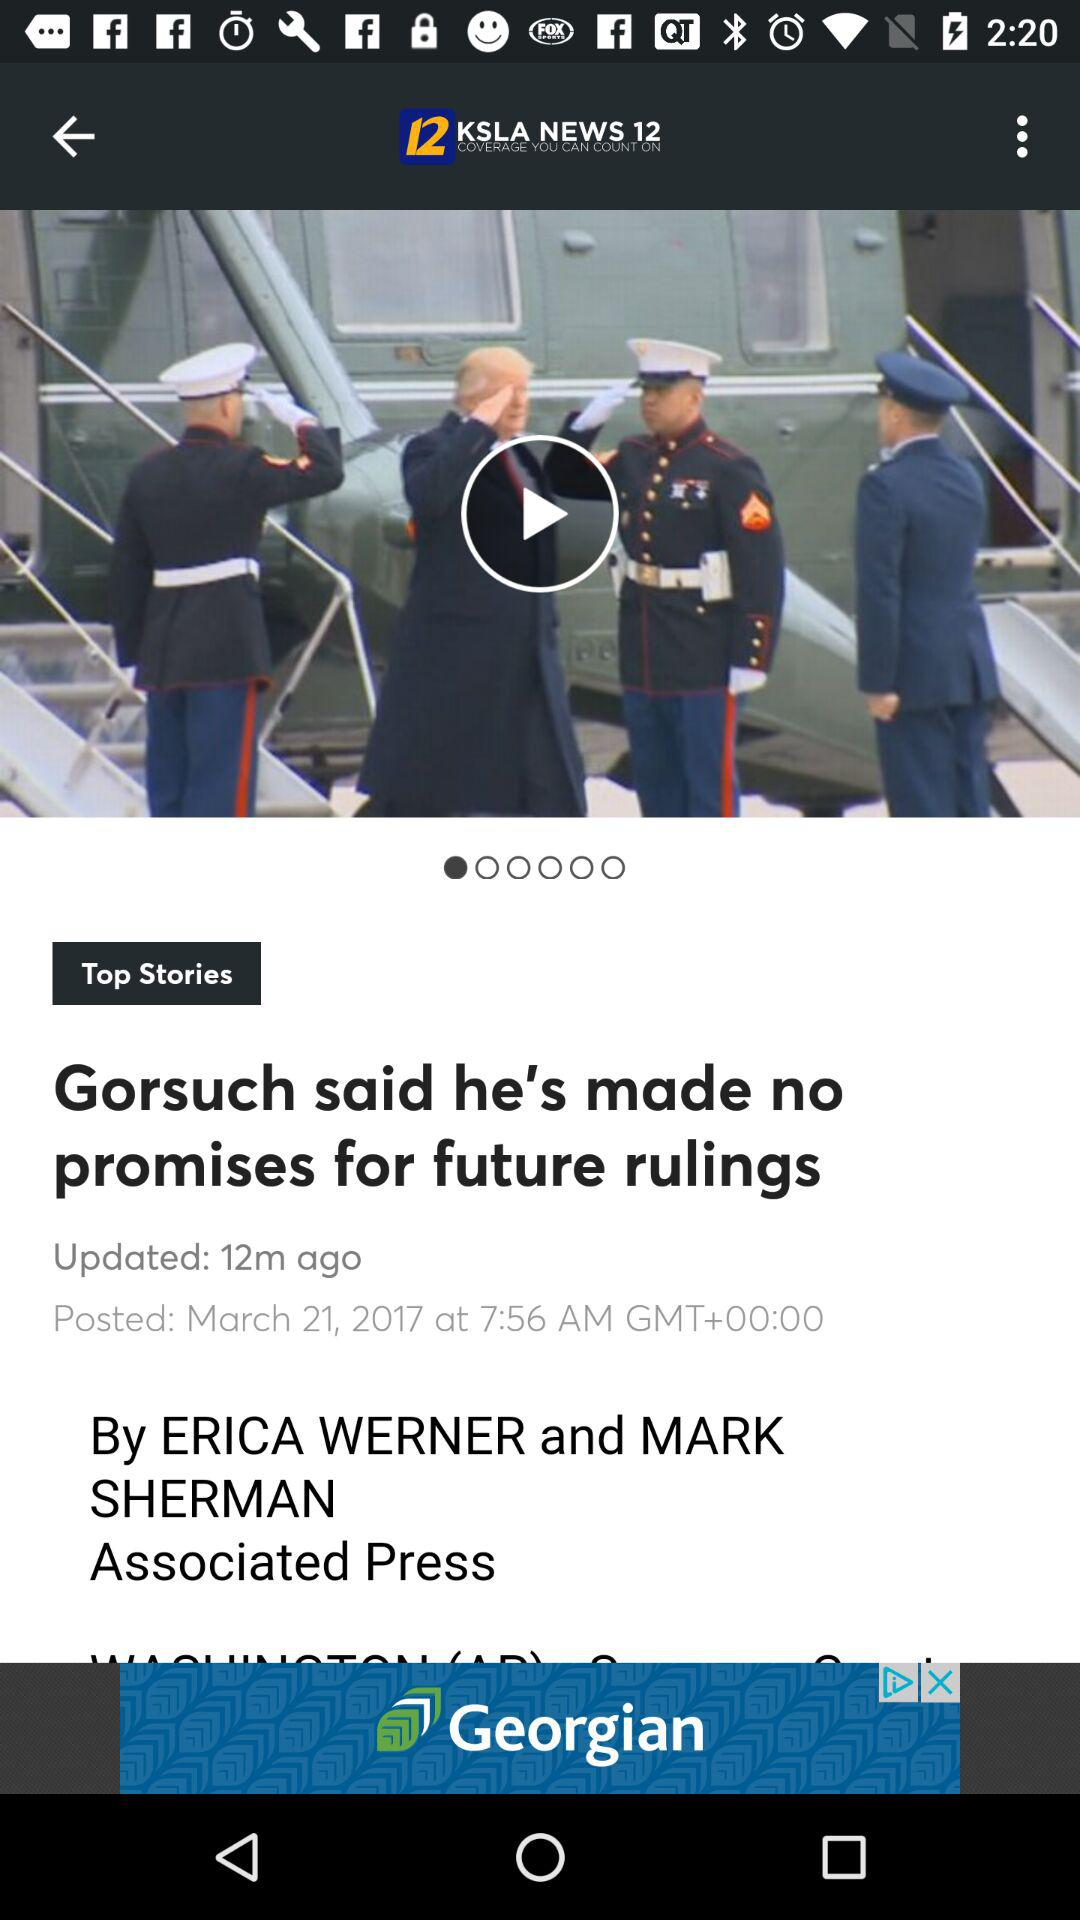When was the article posted? The article was posted on March 21, 2017 at 7:56 a.m. 